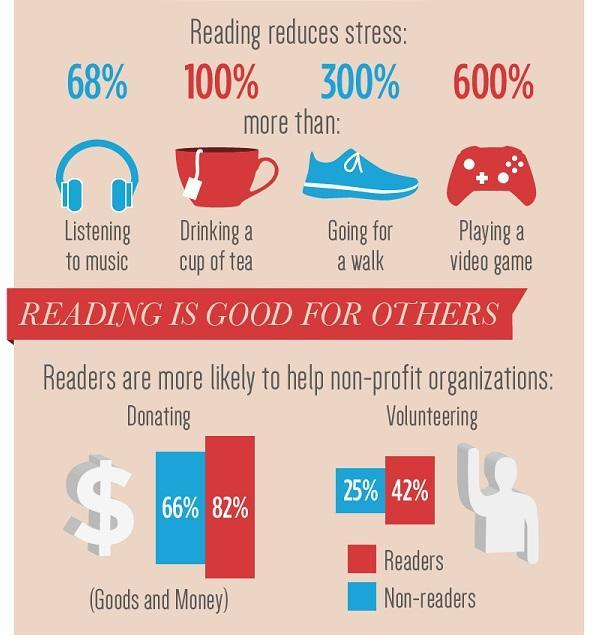What percentage of readers are more likely to volunteer in helping non-profit organization?
Answer the question with a short phrase. 42% What percentage of readers are more likely to help in donating goods & money to non-profit organizations? 82% 